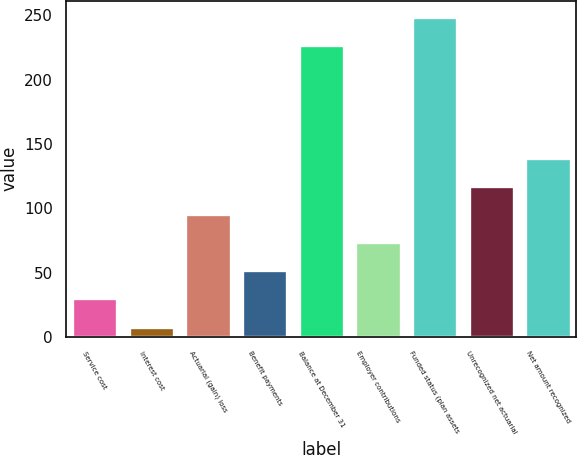Convert chart to OTSL. <chart><loc_0><loc_0><loc_500><loc_500><bar_chart><fcel>Service cost<fcel>Interest cost<fcel>Actuarial (gain) loss<fcel>Benefit payments<fcel>Balance at December 31<fcel>Employer contributions<fcel>Funded status (plan assets<fcel>Unrecognized net actuarial<fcel>Net amount recognized<nl><fcel>29.9<fcel>8<fcel>95.6<fcel>51.8<fcel>227<fcel>73.7<fcel>248.9<fcel>117.5<fcel>139.4<nl></chart> 